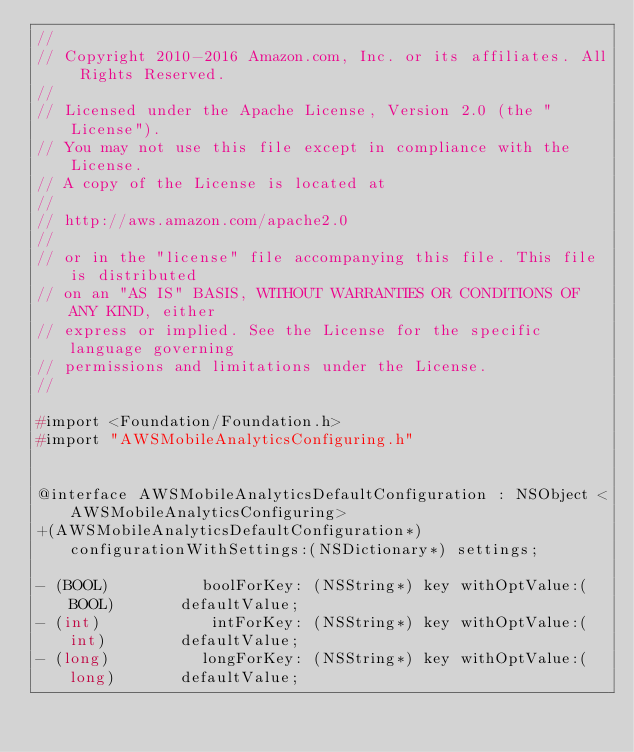Convert code to text. <code><loc_0><loc_0><loc_500><loc_500><_C_>//
// Copyright 2010-2016 Amazon.com, Inc. or its affiliates. All Rights Reserved.
//
// Licensed under the Apache License, Version 2.0 (the "License").
// You may not use this file except in compliance with the License.
// A copy of the License is located at
//
// http://aws.amazon.com/apache2.0
//
// or in the "license" file accompanying this file. This file is distributed
// on an "AS IS" BASIS, WITHOUT WARRANTIES OR CONDITIONS OF ANY KIND, either
// express or implied. See the License for the specific language governing
// permissions and limitations under the License.
//

#import <Foundation/Foundation.h>
#import "AWSMobileAnalyticsConfiguring.h"


@interface AWSMobileAnalyticsDefaultConfiguration : NSObject <AWSMobileAnalyticsConfiguring>
+(AWSMobileAnalyticsDefaultConfiguration*)configurationWithSettings:(NSDictionary*) settings;

- (BOOL)          boolForKey: (NSString*) key withOptValue:(BOOL)       defaultValue;
- (int)            intForKey: (NSString*) key withOptValue:(int)        defaultValue;
- (long)          longForKey: (NSString*) key withOptValue:(long)       defaultValue;</code> 